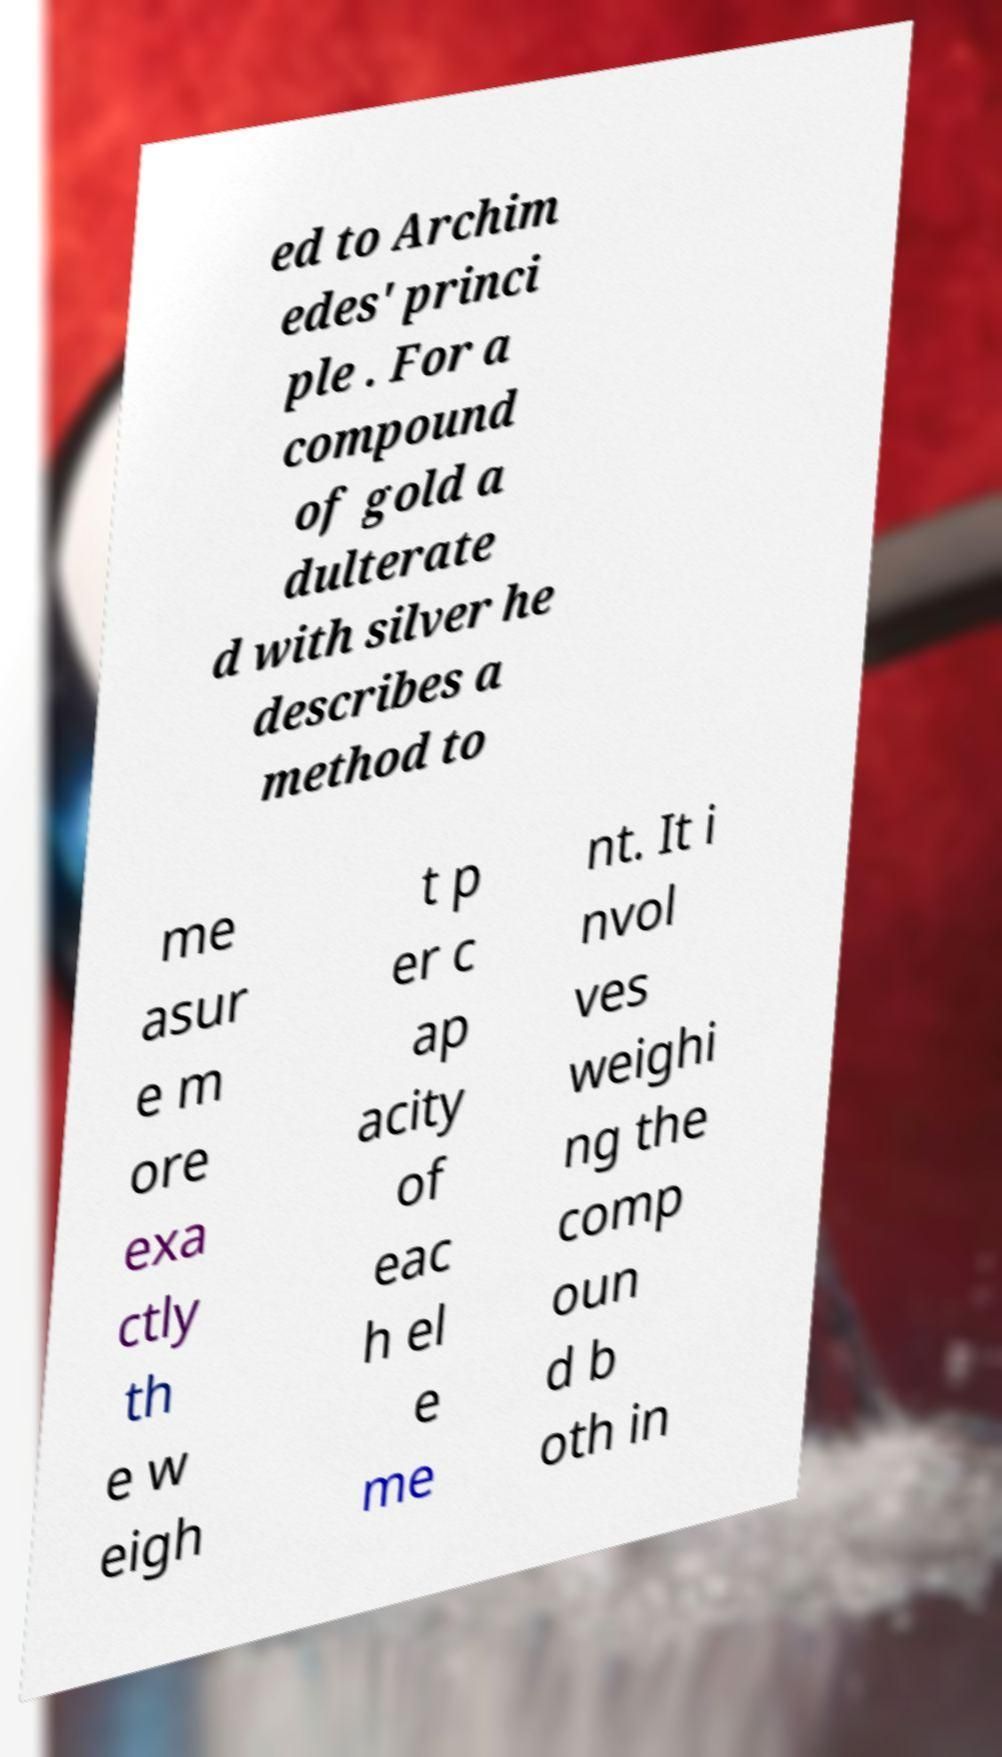Can you read and provide the text displayed in the image?This photo seems to have some interesting text. Can you extract and type it out for me? ed to Archim edes' princi ple . For a compound of gold a dulterate d with silver he describes a method to me asur e m ore exa ctly th e w eigh t p er c ap acity of eac h el e me nt. It i nvol ves weighi ng the comp oun d b oth in 